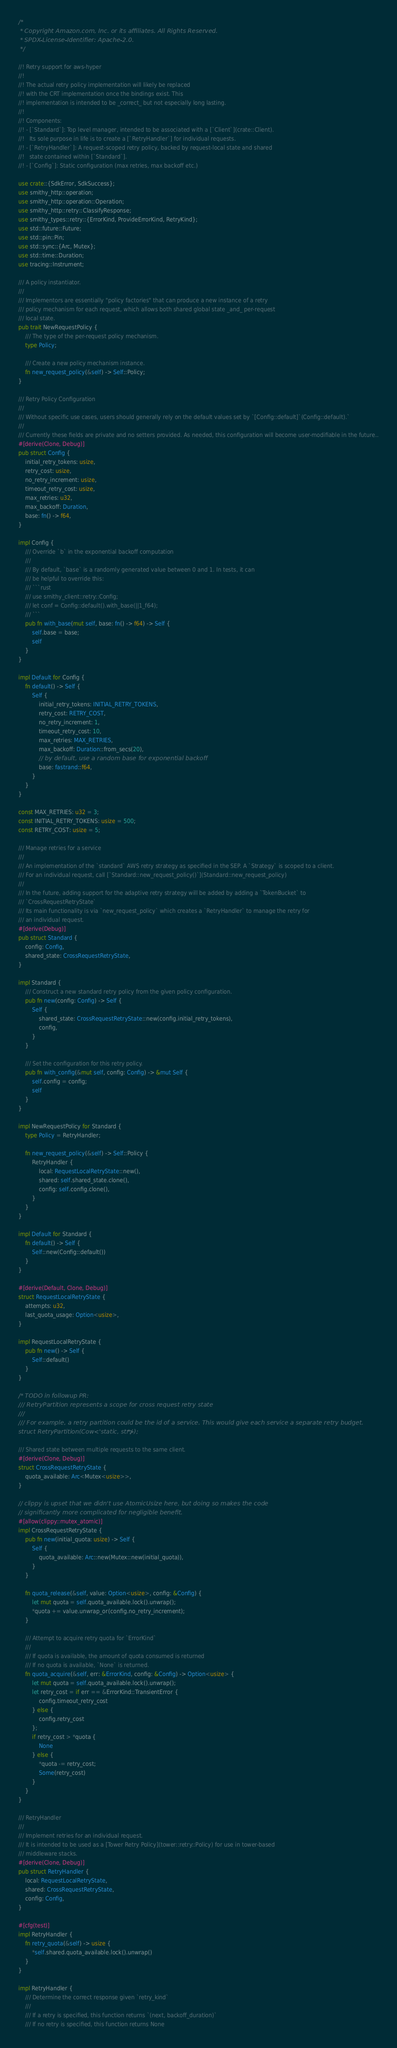<code> <loc_0><loc_0><loc_500><loc_500><_Rust_>/*
 * Copyright Amazon.com, Inc. or its affiliates. All Rights Reserved.
 * SPDX-License-Identifier: Apache-2.0.
 */

//! Retry support for aws-hyper
//!
//! The actual retry policy implementation will likely be replaced
//! with the CRT implementation once the bindings exist. This
//! implementation is intended to be _correct_ but not especially long lasting.
//!
//! Components:
//! - [`Standard`]: Top level manager, intended to be associated with a [`Client`](crate::Client).
//!   Its sole purpose in life is to create a [`RetryHandler`] for individual requests.
//! - [`RetryHandler`]: A request-scoped retry policy, backed by request-local state and shared
//!   state contained within [`Standard`].
//! - [`Config`]: Static configuration (max retries, max backoff etc.)

use crate::{SdkError, SdkSuccess};
use smithy_http::operation;
use smithy_http::operation::Operation;
use smithy_http::retry::ClassifyResponse;
use smithy_types::retry::{ErrorKind, ProvideErrorKind, RetryKind};
use std::future::Future;
use std::pin::Pin;
use std::sync::{Arc, Mutex};
use std::time::Duration;
use tracing::Instrument;

/// A policy instantiator.
///
/// Implementors are essentially "policy factories" that can produce a new instance of a retry
/// policy mechanism for each request, which allows both shared global state _and_ per-request
/// local state.
pub trait NewRequestPolicy {
    /// The type of the per-request policy mechanism.
    type Policy;

    /// Create a new policy mechanism instance.
    fn new_request_policy(&self) -> Self::Policy;
}

/// Retry Policy Configuration
///
/// Without specific use cases, users should generally rely on the default values set by `[Config::default]`(Config::default).`
///
/// Currently these fields are private and no setters provided. As needed, this configuration will become user-modifiable in the future..
#[derive(Clone, Debug)]
pub struct Config {
    initial_retry_tokens: usize,
    retry_cost: usize,
    no_retry_increment: usize,
    timeout_retry_cost: usize,
    max_retries: u32,
    max_backoff: Duration,
    base: fn() -> f64,
}

impl Config {
    /// Override `b` in the exponential backoff computation
    ///
    /// By default, `base` is a randomly generated value between 0 and 1. In tests, it can
    /// be helpful to override this:
    /// ```rust
    /// use smithy_client::retry::Config;
    /// let conf = Config::default().with_base(||1_f64);
    /// ```
    pub fn with_base(mut self, base: fn() -> f64) -> Self {
        self.base = base;
        self
    }
}

impl Default for Config {
    fn default() -> Self {
        Self {
            initial_retry_tokens: INITIAL_RETRY_TOKENS,
            retry_cost: RETRY_COST,
            no_retry_increment: 1,
            timeout_retry_cost: 10,
            max_retries: MAX_RETRIES,
            max_backoff: Duration::from_secs(20),
            // by default, use a random base for exponential backoff
            base: fastrand::f64,
        }
    }
}

const MAX_RETRIES: u32 = 3;
const INITIAL_RETRY_TOKENS: usize = 500;
const RETRY_COST: usize = 5;

/// Manage retries for a service
///
/// An implementation of the `standard` AWS retry strategy as specified in the SEP. A `Strategy` is scoped to a client.
/// For an individual request, call [`Standard::new_request_policy()`](Standard::new_request_policy)
///
/// In the future, adding support for the adaptive retry strategy will be added by adding a `TokenBucket` to
/// `CrossRequestRetryState`
/// Its main functionality is via `new_request_policy` which creates a `RetryHandler` to manage the retry for
/// an individual request.
#[derive(Debug)]
pub struct Standard {
    config: Config,
    shared_state: CrossRequestRetryState,
}

impl Standard {
    /// Construct a new standard retry policy from the given policy configuration.
    pub fn new(config: Config) -> Self {
        Self {
            shared_state: CrossRequestRetryState::new(config.initial_retry_tokens),
            config,
        }
    }

    /// Set the configuration for this retry policy.
    pub fn with_config(&mut self, config: Config) -> &mut Self {
        self.config = config;
        self
    }
}

impl NewRequestPolicy for Standard {
    type Policy = RetryHandler;

    fn new_request_policy(&self) -> Self::Policy {
        RetryHandler {
            local: RequestLocalRetryState::new(),
            shared: self.shared_state.clone(),
            config: self.config.clone(),
        }
    }
}

impl Default for Standard {
    fn default() -> Self {
        Self::new(Config::default())
    }
}

#[derive(Default, Clone, Debug)]
struct RequestLocalRetryState {
    attempts: u32,
    last_quota_usage: Option<usize>,
}

impl RequestLocalRetryState {
    pub fn new() -> Self {
        Self::default()
    }
}

/* TODO in followup PR:
/// RetryPartition represents a scope for cross request retry state
///
/// For example, a retry partition could be the id of a service. This would give each service a separate retry budget.
struct RetryPartition(Cow<'static, str>); */

/// Shared state between multiple requests to the same client.
#[derive(Clone, Debug)]
struct CrossRequestRetryState {
    quota_available: Arc<Mutex<usize>>,
}

// clippy is upset that we didn't use AtomicUsize here, but doing so makes the code
// significantly more complicated for negligible benefit.
#[allow(clippy::mutex_atomic)]
impl CrossRequestRetryState {
    pub fn new(initial_quota: usize) -> Self {
        Self {
            quota_available: Arc::new(Mutex::new(initial_quota)),
        }
    }

    fn quota_release(&self, value: Option<usize>, config: &Config) {
        let mut quota = self.quota_available.lock().unwrap();
        *quota += value.unwrap_or(config.no_retry_increment);
    }

    /// Attempt to acquire retry quota for `ErrorKind`
    ///
    /// If quota is available, the amount of quota consumed is returned
    /// If no quota is available, `None` is returned.
    fn quota_acquire(&self, err: &ErrorKind, config: &Config) -> Option<usize> {
        let mut quota = self.quota_available.lock().unwrap();
        let retry_cost = if err == &ErrorKind::TransientError {
            config.timeout_retry_cost
        } else {
            config.retry_cost
        };
        if retry_cost > *quota {
            None
        } else {
            *quota -= retry_cost;
            Some(retry_cost)
        }
    }
}

/// RetryHandler
///
/// Implement retries for an individual request.
/// It is intended to be used as a [Tower Retry Policy](tower::retry::Policy) for use in tower-based
/// middleware stacks.
#[derive(Clone, Debug)]
pub struct RetryHandler {
    local: RequestLocalRetryState,
    shared: CrossRequestRetryState,
    config: Config,
}

#[cfg(test)]
impl RetryHandler {
    fn retry_quota(&self) -> usize {
        *self.shared.quota_available.lock().unwrap()
    }
}

impl RetryHandler {
    /// Determine the correct response given `retry_kind`
    ///
    /// If a retry is specified, this function returns `(next, backoff_duration)`
    /// If no retry is specified, this function returns None</code> 